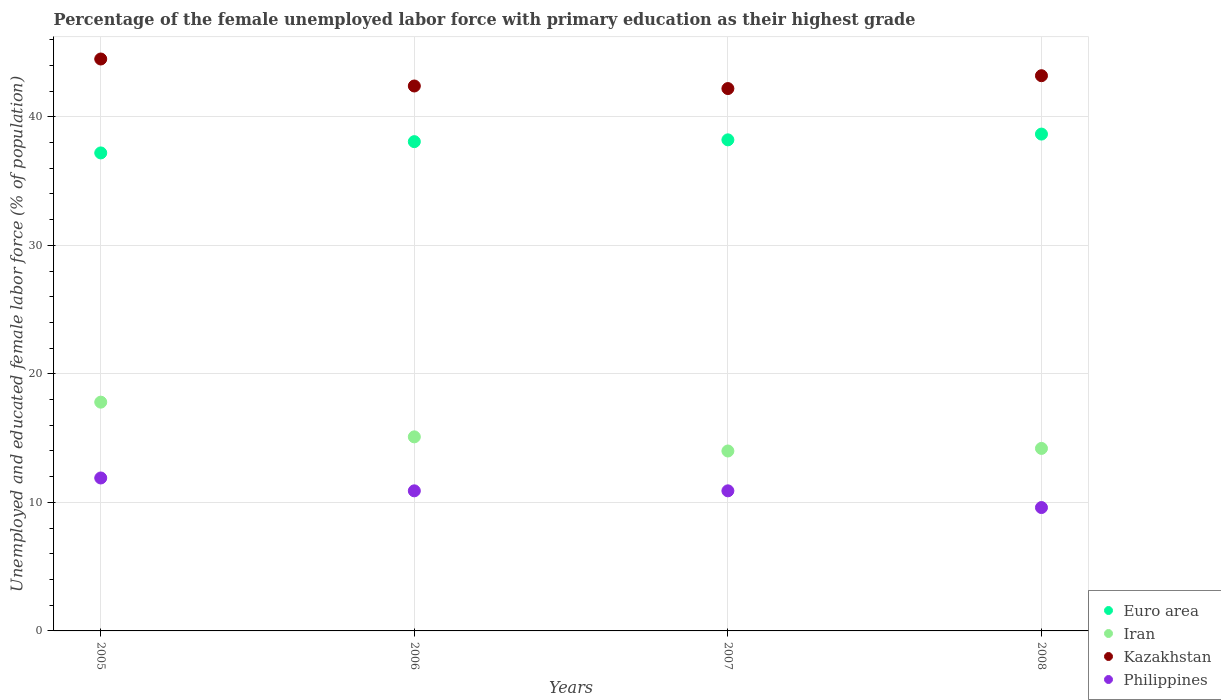Is the number of dotlines equal to the number of legend labels?
Your answer should be very brief. Yes. What is the percentage of the unemployed female labor force with primary education in Iran in 2005?
Your answer should be compact. 17.8. Across all years, what is the maximum percentage of the unemployed female labor force with primary education in Philippines?
Give a very brief answer. 11.9. Across all years, what is the minimum percentage of the unemployed female labor force with primary education in Euro area?
Offer a terse response. 37.19. In which year was the percentage of the unemployed female labor force with primary education in Euro area maximum?
Make the answer very short. 2008. In which year was the percentage of the unemployed female labor force with primary education in Euro area minimum?
Give a very brief answer. 2005. What is the total percentage of the unemployed female labor force with primary education in Philippines in the graph?
Give a very brief answer. 43.3. What is the difference between the percentage of the unemployed female labor force with primary education in Euro area in 2005 and that in 2008?
Offer a very short reply. -1.47. What is the difference between the percentage of the unemployed female labor force with primary education in Kazakhstan in 2006 and the percentage of the unemployed female labor force with primary education in Iran in 2007?
Provide a succinct answer. 28.4. What is the average percentage of the unemployed female labor force with primary education in Kazakhstan per year?
Your answer should be very brief. 43.08. In the year 2006, what is the difference between the percentage of the unemployed female labor force with primary education in Euro area and percentage of the unemployed female labor force with primary education in Kazakhstan?
Make the answer very short. -4.33. What is the ratio of the percentage of the unemployed female labor force with primary education in Euro area in 2005 to that in 2007?
Your answer should be compact. 0.97. What is the difference between the highest and the lowest percentage of the unemployed female labor force with primary education in Euro area?
Your response must be concise. 1.47. Is it the case that in every year, the sum of the percentage of the unemployed female labor force with primary education in Euro area and percentage of the unemployed female labor force with primary education in Iran  is greater than the sum of percentage of the unemployed female labor force with primary education in Kazakhstan and percentage of the unemployed female labor force with primary education in Philippines?
Make the answer very short. No. Does the percentage of the unemployed female labor force with primary education in Euro area monotonically increase over the years?
Provide a succinct answer. Yes. Is the percentage of the unemployed female labor force with primary education in Iran strictly less than the percentage of the unemployed female labor force with primary education in Philippines over the years?
Ensure brevity in your answer.  No. How many dotlines are there?
Provide a short and direct response. 4. Does the graph contain grids?
Keep it short and to the point. Yes. How many legend labels are there?
Your response must be concise. 4. What is the title of the graph?
Your answer should be compact. Percentage of the female unemployed labor force with primary education as their highest grade. Does "Honduras" appear as one of the legend labels in the graph?
Offer a very short reply. No. What is the label or title of the X-axis?
Ensure brevity in your answer.  Years. What is the label or title of the Y-axis?
Offer a terse response. Unemployed and educated female labor force (% of population). What is the Unemployed and educated female labor force (% of population) of Euro area in 2005?
Provide a succinct answer. 37.19. What is the Unemployed and educated female labor force (% of population) in Iran in 2005?
Give a very brief answer. 17.8. What is the Unemployed and educated female labor force (% of population) in Kazakhstan in 2005?
Your answer should be very brief. 44.5. What is the Unemployed and educated female labor force (% of population) of Philippines in 2005?
Your answer should be compact. 11.9. What is the Unemployed and educated female labor force (% of population) in Euro area in 2006?
Your answer should be very brief. 38.07. What is the Unemployed and educated female labor force (% of population) in Iran in 2006?
Your answer should be compact. 15.1. What is the Unemployed and educated female labor force (% of population) in Kazakhstan in 2006?
Make the answer very short. 42.4. What is the Unemployed and educated female labor force (% of population) in Philippines in 2006?
Keep it short and to the point. 10.9. What is the Unemployed and educated female labor force (% of population) in Euro area in 2007?
Offer a terse response. 38.21. What is the Unemployed and educated female labor force (% of population) of Iran in 2007?
Make the answer very short. 14. What is the Unemployed and educated female labor force (% of population) of Kazakhstan in 2007?
Offer a very short reply. 42.2. What is the Unemployed and educated female labor force (% of population) in Philippines in 2007?
Keep it short and to the point. 10.9. What is the Unemployed and educated female labor force (% of population) in Euro area in 2008?
Your response must be concise. 38.66. What is the Unemployed and educated female labor force (% of population) in Iran in 2008?
Offer a very short reply. 14.2. What is the Unemployed and educated female labor force (% of population) in Kazakhstan in 2008?
Keep it short and to the point. 43.2. What is the Unemployed and educated female labor force (% of population) in Philippines in 2008?
Ensure brevity in your answer.  9.6. Across all years, what is the maximum Unemployed and educated female labor force (% of population) of Euro area?
Your answer should be compact. 38.66. Across all years, what is the maximum Unemployed and educated female labor force (% of population) in Iran?
Offer a very short reply. 17.8. Across all years, what is the maximum Unemployed and educated female labor force (% of population) of Kazakhstan?
Ensure brevity in your answer.  44.5. Across all years, what is the maximum Unemployed and educated female labor force (% of population) of Philippines?
Make the answer very short. 11.9. Across all years, what is the minimum Unemployed and educated female labor force (% of population) in Euro area?
Provide a short and direct response. 37.19. Across all years, what is the minimum Unemployed and educated female labor force (% of population) in Kazakhstan?
Provide a succinct answer. 42.2. Across all years, what is the minimum Unemployed and educated female labor force (% of population) of Philippines?
Keep it short and to the point. 9.6. What is the total Unemployed and educated female labor force (% of population) in Euro area in the graph?
Make the answer very short. 152.13. What is the total Unemployed and educated female labor force (% of population) in Iran in the graph?
Provide a succinct answer. 61.1. What is the total Unemployed and educated female labor force (% of population) in Kazakhstan in the graph?
Provide a succinct answer. 172.3. What is the total Unemployed and educated female labor force (% of population) of Philippines in the graph?
Offer a very short reply. 43.3. What is the difference between the Unemployed and educated female labor force (% of population) in Euro area in 2005 and that in 2006?
Your answer should be compact. -0.88. What is the difference between the Unemployed and educated female labor force (% of population) in Kazakhstan in 2005 and that in 2006?
Your response must be concise. 2.1. What is the difference between the Unemployed and educated female labor force (% of population) of Philippines in 2005 and that in 2006?
Ensure brevity in your answer.  1. What is the difference between the Unemployed and educated female labor force (% of population) in Euro area in 2005 and that in 2007?
Make the answer very short. -1.02. What is the difference between the Unemployed and educated female labor force (% of population) of Iran in 2005 and that in 2007?
Provide a succinct answer. 3.8. What is the difference between the Unemployed and educated female labor force (% of population) in Philippines in 2005 and that in 2007?
Make the answer very short. 1. What is the difference between the Unemployed and educated female labor force (% of population) of Euro area in 2005 and that in 2008?
Provide a short and direct response. -1.47. What is the difference between the Unemployed and educated female labor force (% of population) of Iran in 2005 and that in 2008?
Your answer should be compact. 3.6. What is the difference between the Unemployed and educated female labor force (% of population) of Philippines in 2005 and that in 2008?
Give a very brief answer. 2.3. What is the difference between the Unemployed and educated female labor force (% of population) in Euro area in 2006 and that in 2007?
Ensure brevity in your answer.  -0.14. What is the difference between the Unemployed and educated female labor force (% of population) in Iran in 2006 and that in 2007?
Offer a terse response. 1.1. What is the difference between the Unemployed and educated female labor force (% of population) of Kazakhstan in 2006 and that in 2007?
Your answer should be very brief. 0.2. What is the difference between the Unemployed and educated female labor force (% of population) of Euro area in 2006 and that in 2008?
Offer a terse response. -0.59. What is the difference between the Unemployed and educated female labor force (% of population) of Kazakhstan in 2006 and that in 2008?
Provide a short and direct response. -0.8. What is the difference between the Unemployed and educated female labor force (% of population) of Philippines in 2006 and that in 2008?
Your answer should be very brief. 1.3. What is the difference between the Unemployed and educated female labor force (% of population) of Euro area in 2007 and that in 2008?
Offer a very short reply. -0.45. What is the difference between the Unemployed and educated female labor force (% of population) in Kazakhstan in 2007 and that in 2008?
Your answer should be compact. -1. What is the difference between the Unemployed and educated female labor force (% of population) of Philippines in 2007 and that in 2008?
Ensure brevity in your answer.  1.3. What is the difference between the Unemployed and educated female labor force (% of population) in Euro area in 2005 and the Unemployed and educated female labor force (% of population) in Iran in 2006?
Give a very brief answer. 22.09. What is the difference between the Unemployed and educated female labor force (% of population) of Euro area in 2005 and the Unemployed and educated female labor force (% of population) of Kazakhstan in 2006?
Your answer should be very brief. -5.21. What is the difference between the Unemployed and educated female labor force (% of population) of Euro area in 2005 and the Unemployed and educated female labor force (% of population) of Philippines in 2006?
Your answer should be compact. 26.29. What is the difference between the Unemployed and educated female labor force (% of population) of Iran in 2005 and the Unemployed and educated female labor force (% of population) of Kazakhstan in 2006?
Your answer should be compact. -24.6. What is the difference between the Unemployed and educated female labor force (% of population) in Kazakhstan in 2005 and the Unemployed and educated female labor force (% of population) in Philippines in 2006?
Provide a succinct answer. 33.6. What is the difference between the Unemployed and educated female labor force (% of population) in Euro area in 2005 and the Unemployed and educated female labor force (% of population) in Iran in 2007?
Your answer should be very brief. 23.19. What is the difference between the Unemployed and educated female labor force (% of population) in Euro area in 2005 and the Unemployed and educated female labor force (% of population) in Kazakhstan in 2007?
Your answer should be compact. -5.01. What is the difference between the Unemployed and educated female labor force (% of population) of Euro area in 2005 and the Unemployed and educated female labor force (% of population) of Philippines in 2007?
Ensure brevity in your answer.  26.29. What is the difference between the Unemployed and educated female labor force (% of population) in Iran in 2005 and the Unemployed and educated female labor force (% of population) in Kazakhstan in 2007?
Ensure brevity in your answer.  -24.4. What is the difference between the Unemployed and educated female labor force (% of population) in Kazakhstan in 2005 and the Unemployed and educated female labor force (% of population) in Philippines in 2007?
Provide a short and direct response. 33.6. What is the difference between the Unemployed and educated female labor force (% of population) of Euro area in 2005 and the Unemployed and educated female labor force (% of population) of Iran in 2008?
Provide a succinct answer. 22.99. What is the difference between the Unemployed and educated female labor force (% of population) in Euro area in 2005 and the Unemployed and educated female labor force (% of population) in Kazakhstan in 2008?
Provide a succinct answer. -6.01. What is the difference between the Unemployed and educated female labor force (% of population) of Euro area in 2005 and the Unemployed and educated female labor force (% of population) of Philippines in 2008?
Your answer should be very brief. 27.59. What is the difference between the Unemployed and educated female labor force (% of population) of Iran in 2005 and the Unemployed and educated female labor force (% of population) of Kazakhstan in 2008?
Give a very brief answer. -25.4. What is the difference between the Unemployed and educated female labor force (% of population) in Kazakhstan in 2005 and the Unemployed and educated female labor force (% of population) in Philippines in 2008?
Your response must be concise. 34.9. What is the difference between the Unemployed and educated female labor force (% of population) in Euro area in 2006 and the Unemployed and educated female labor force (% of population) in Iran in 2007?
Offer a terse response. 24.07. What is the difference between the Unemployed and educated female labor force (% of population) of Euro area in 2006 and the Unemployed and educated female labor force (% of population) of Kazakhstan in 2007?
Keep it short and to the point. -4.13. What is the difference between the Unemployed and educated female labor force (% of population) in Euro area in 2006 and the Unemployed and educated female labor force (% of population) in Philippines in 2007?
Give a very brief answer. 27.17. What is the difference between the Unemployed and educated female labor force (% of population) of Iran in 2006 and the Unemployed and educated female labor force (% of population) of Kazakhstan in 2007?
Provide a short and direct response. -27.1. What is the difference between the Unemployed and educated female labor force (% of population) of Kazakhstan in 2006 and the Unemployed and educated female labor force (% of population) of Philippines in 2007?
Offer a very short reply. 31.5. What is the difference between the Unemployed and educated female labor force (% of population) of Euro area in 2006 and the Unemployed and educated female labor force (% of population) of Iran in 2008?
Make the answer very short. 23.87. What is the difference between the Unemployed and educated female labor force (% of population) of Euro area in 2006 and the Unemployed and educated female labor force (% of population) of Kazakhstan in 2008?
Your answer should be compact. -5.13. What is the difference between the Unemployed and educated female labor force (% of population) in Euro area in 2006 and the Unemployed and educated female labor force (% of population) in Philippines in 2008?
Make the answer very short. 28.47. What is the difference between the Unemployed and educated female labor force (% of population) in Iran in 2006 and the Unemployed and educated female labor force (% of population) in Kazakhstan in 2008?
Offer a terse response. -28.1. What is the difference between the Unemployed and educated female labor force (% of population) of Kazakhstan in 2006 and the Unemployed and educated female labor force (% of population) of Philippines in 2008?
Provide a short and direct response. 32.8. What is the difference between the Unemployed and educated female labor force (% of population) in Euro area in 2007 and the Unemployed and educated female labor force (% of population) in Iran in 2008?
Make the answer very short. 24.01. What is the difference between the Unemployed and educated female labor force (% of population) in Euro area in 2007 and the Unemployed and educated female labor force (% of population) in Kazakhstan in 2008?
Your answer should be compact. -4.99. What is the difference between the Unemployed and educated female labor force (% of population) of Euro area in 2007 and the Unemployed and educated female labor force (% of population) of Philippines in 2008?
Ensure brevity in your answer.  28.61. What is the difference between the Unemployed and educated female labor force (% of population) in Iran in 2007 and the Unemployed and educated female labor force (% of population) in Kazakhstan in 2008?
Give a very brief answer. -29.2. What is the difference between the Unemployed and educated female labor force (% of population) of Kazakhstan in 2007 and the Unemployed and educated female labor force (% of population) of Philippines in 2008?
Provide a short and direct response. 32.6. What is the average Unemployed and educated female labor force (% of population) in Euro area per year?
Give a very brief answer. 38.03. What is the average Unemployed and educated female labor force (% of population) in Iran per year?
Your response must be concise. 15.28. What is the average Unemployed and educated female labor force (% of population) in Kazakhstan per year?
Offer a terse response. 43.08. What is the average Unemployed and educated female labor force (% of population) of Philippines per year?
Offer a terse response. 10.82. In the year 2005, what is the difference between the Unemployed and educated female labor force (% of population) in Euro area and Unemployed and educated female labor force (% of population) in Iran?
Offer a very short reply. 19.39. In the year 2005, what is the difference between the Unemployed and educated female labor force (% of population) of Euro area and Unemployed and educated female labor force (% of population) of Kazakhstan?
Your answer should be compact. -7.31. In the year 2005, what is the difference between the Unemployed and educated female labor force (% of population) in Euro area and Unemployed and educated female labor force (% of population) in Philippines?
Your response must be concise. 25.29. In the year 2005, what is the difference between the Unemployed and educated female labor force (% of population) in Iran and Unemployed and educated female labor force (% of population) in Kazakhstan?
Provide a succinct answer. -26.7. In the year 2005, what is the difference between the Unemployed and educated female labor force (% of population) of Iran and Unemployed and educated female labor force (% of population) of Philippines?
Offer a very short reply. 5.9. In the year 2005, what is the difference between the Unemployed and educated female labor force (% of population) in Kazakhstan and Unemployed and educated female labor force (% of population) in Philippines?
Your response must be concise. 32.6. In the year 2006, what is the difference between the Unemployed and educated female labor force (% of population) in Euro area and Unemployed and educated female labor force (% of population) in Iran?
Make the answer very short. 22.97. In the year 2006, what is the difference between the Unemployed and educated female labor force (% of population) in Euro area and Unemployed and educated female labor force (% of population) in Kazakhstan?
Offer a terse response. -4.33. In the year 2006, what is the difference between the Unemployed and educated female labor force (% of population) of Euro area and Unemployed and educated female labor force (% of population) of Philippines?
Your answer should be compact. 27.17. In the year 2006, what is the difference between the Unemployed and educated female labor force (% of population) of Iran and Unemployed and educated female labor force (% of population) of Kazakhstan?
Provide a short and direct response. -27.3. In the year 2006, what is the difference between the Unemployed and educated female labor force (% of population) in Kazakhstan and Unemployed and educated female labor force (% of population) in Philippines?
Provide a short and direct response. 31.5. In the year 2007, what is the difference between the Unemployed and educated female labor force (% of population) of Euro area and Unemployed and educated female labor force (% of population) of Iran?
Make the answer very short. 24.21. In the year 2007, what is the difference between the Unemployed and educated female labor force (% of population) of Euro area and Unemployed and educated female labor force (% of population) of Kazakhstan?
Offer a terse response. -3.99. In the year 2007, what is the difference between the Unemployed and educated female labor force (% of population) in Euro area and Unemployed and educated female labor force (% of population) in Philippines?
Your answer should be compact. 27.31. In the year 2007, what is the difference between the Unemployed and educated female labor force (% of population) in Iran and Unemployed and educated female labor force (% of population) in Kazakhstan?
Your response must be concise. -28.2. In the year 2007, what is the difference between the Unemployed and educated female labor force (% of population) of Kazakhstan and Unemployed and educated female labor force (% of population) of Philippines?
Provide a succinct answer. 31.3. In the year 2008, what is the difference between the Unemployed and educated female labor force (% of population) in Euro area and Unemployed and educated female labor force (% of population) in Iran?
Your answer should be compact. 24.46. In the year 2008, what is the difference between the Unemployed and educated female labor force (% of population) in Euro area and Unemployed and educated female labor force (% of population) in Kazakhstan?
Provide a short and direct response. -4.54. In the year 2008, what is the difference between the Unemployed and educated female labor force (% of population) in Euro area and Unemployed and educated female labor force (% of population) in Philippines?
Your answer should be very brief. 29.06. In the year 2008, what is the difference between the Unemployed and educated female labor force (% of population) in Iran and Unemployed and educated female labor force (% of population) in Kazakhstan?
Provide a short and direct response. -29. In the year 2008, what is the difference between the Unemployed and educated female labor force (% of population) of Iran and Unemployed and educated female labor force (% of population) of Philippines?
Offer a very short reply. 4.6. In the year 2008, what is the difference between the Unemployed and educated female labor force (% of population) in Kazakhstan and Unemployed and educated female labor force (% of population) in Philippines?
Ensure brevity in your answer.  33.6. What is the ratio of the Unemployed and educated female labor force (% of population) in Euro area in 2005 to that in 2006?
Provide a succinct answer. 0.98. What is the ratio of the Unemployed and educated female labor force (% of population) of Iran in 2005 to that in 2006?
Your answer should be very brief. 1.18. What is the ratio of the Unemployed and educated female labor force (% of population) of Kazakhstan in 2005 to that in 2006?
Make the answer very short. 1.05. What is the ratio of the Unemployed and educated female labor force (% of population) in Philippines in 2005 to that in 2006?
Your response must be concise. 1.09. What is the ratio of the Unemployed and educated female labor force (% of population) of Euro area in 2005 to that in 2007?
Provide a short and direct response. 0.97. What is the ratio of the Unemployed and educated female labor force (% of population) in Iran in 2005 to that in 2007?
Keep it short and to the point. 1.27. What is the ratio of the Unemployed and educated female labor force (% of population) of Kazakhstan in 2005 to that in 2007?
Provide a short and direct response. 1.05. What is the ratio of the Unemployed and educated female labor force (% of population) in Philippines in 2005 to that in 2007?
Your answer should be very brief. 1.09. What is the ratio of the Unemployed and educated female labor force (% of population) in Euro area in 2005 to that in 2008?
Ensure brevity in your answer.  0.96. What is the ratio of the Unemployed and educated female labor force (% of population) of Iran in 2005 to that in 2008?
Offer a terse response. 1.25. What is the ratio of the Unemployed and educated female labor force (% of population) in Kazakhstan in 2005 to that in 2008?
Provide a short and direct response. 1.03. What is the ratio of the Unemployed and educated female labor force (% of population) of Philippines in 2005 to that in 2008?
Keep it short and to the point. 1.24. What is the ratio of the Unemployed and educated female labor force (% of population) of Euro area in 2006 to that in 2007?
Your answer should be compact. 1. What is the ratio of the Unemployed and educated female labor force (% of population) of Iran in 2006 to that in 2007?
Offer a very short reply. 1.08. What is the ratio of the Unemployed and educated female labor force (% of population) of Philippines in 2006 to that in 2007?
Your response must be concise. 1. What is the ratio of the Unemployed and educated female labor force (% of population) in Iran in 2006 to that in 2008?
Give a very brief answer. 1.06. What is the ratio of the Unemployed and educated female labor force (% of population) of Kazakhstan in 2006 to that in 2008?
Ensure brevity in your answer.  0.98. What is the ratio of the Unemployed and educated female labor force (% of population) in Philippines in 2006 to that in 2008?
Make the answer very short. 1.14. What is the ratio of the Unemployed and educated female labor force (% of population) in Euro area in 2007 to that in 2008?
Offer a terse response. 0.99. What is the ratio of the Unemployed and educated female labor force (% of population) in Iran in 2007 to that in 2008?
Offer a terse response. 0.99. What is the ratio of the Unemployed and educated female labor force (% of population) of Kazakhstan in 2007 to that in 2008?
Give a very brief answer. 0.98. What is the ratio of the Unemployed and educated female labor force (% of population) in Philippines in 2007 to that in 2008?
Make the answer very short. 1.14. What is the difference between the highest and the second highest Unemployed and educated female labor force (% of population) in Euro area?
Provide a succinct answer. 0.45. What is the difference between the highest and the second highest Unemployed and educated female labor force (% of population) of Kazakhstan?
Your answer should be compact. 1.3. What is the difference between the highest and the second highest Unemployed and educated female labor force (% of population) of Philippines?
Provide a succinct answer. 1. What is the difference between the highest and the lowest Unemployed and educated female labor force (% of population) of Euro area?
Keep it short and to the point. 1.47. What is the difference between the highest and the lowest Unemployed and educated female labor force (% of population) in Iran?
Ensure brevity in your answer.  3.8. What is the difference between the highest and the lowest Unemployed and educated female labor force (% of population) in Kazakhstan?
Keep it short and to the point. 2.3. What is the difference between the highest and the lowest Unemployed and educated female labor force (% of population) of Philippines?
Ensure brevity in your answer.  2.3. 